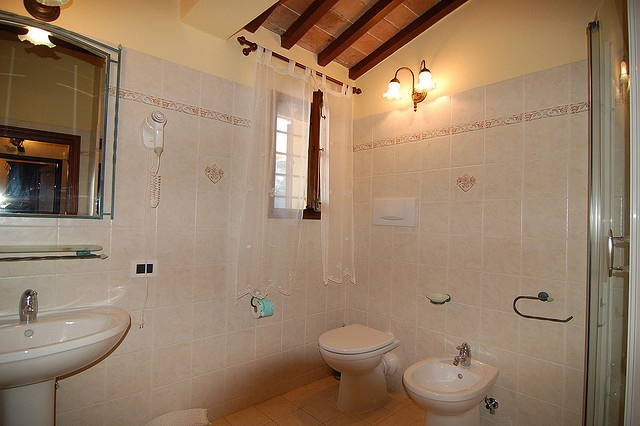Describe the objects in this image and their specific colors. I can see sink in tan, darkgray, and gray tones, toilet in tan, maroon, and gray tones, and hair drier in tan, darkgray, and gray tones in this image. 